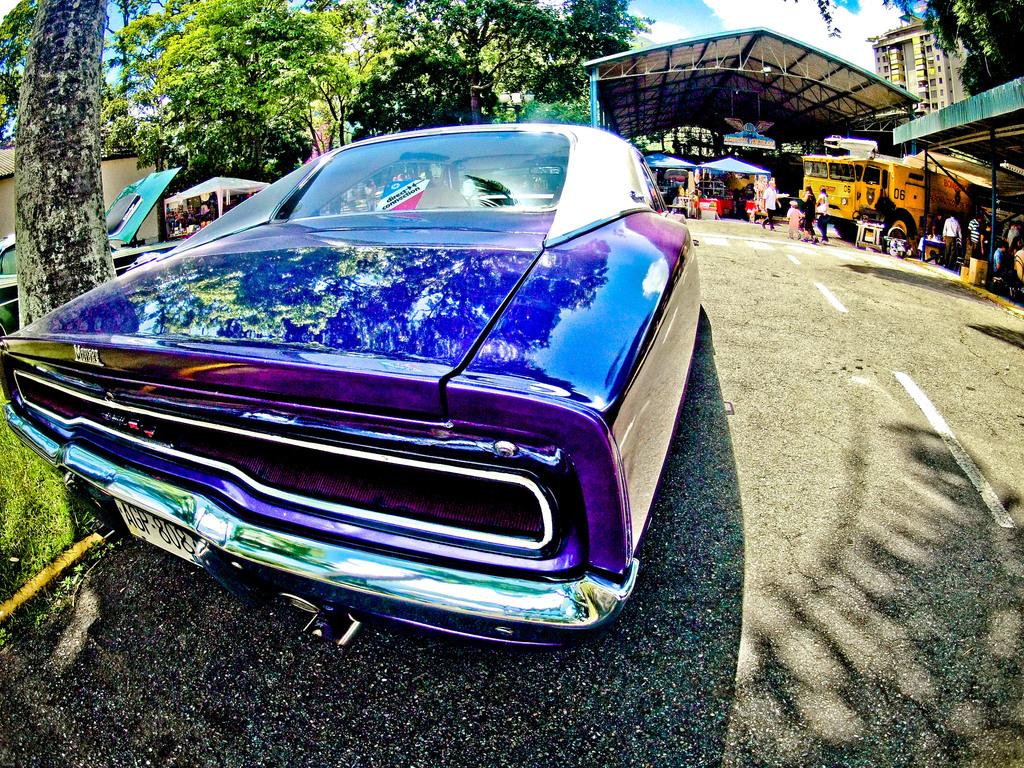What is the main subject in the foreground of the image? There is a car in the foreground of the image. What can be seen in the background of the image? There are vehicles, a shelter, a building, trees, and other objects in the background of the image. What is the surface at the bottom of the image? There is a road at the bottom of the image. What type of basket is hanging from the tree in the image? There is no basket hanging from a tree in the image. Is there a pipe visible in the image? There is no pipe visible in the image. 